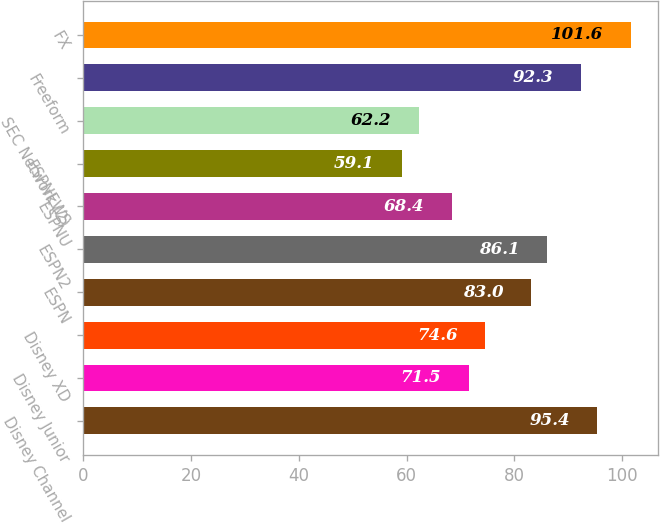Convert chart to OTSL. <chart><loc_0><loc_0><loc_500><loc_500><bar_chart><fcel>Disney Channel<fcel>Disney Junior<fcel>Disney XD<fcel>ESPN<fcel>ESPN2<fcel>ESPNU<fcel>ESPNEWS<fcel>SEC Network (2)<fcel>Freeform<fcel>FX<nl><fcel>95.4<fcel>71.5<fcel>74.6<fcel>83<fcel>86.1<fcel>68.4<fcel>59.1<fcel>62.2<fcel>92.3<fcel>101.6<nl></chart> 